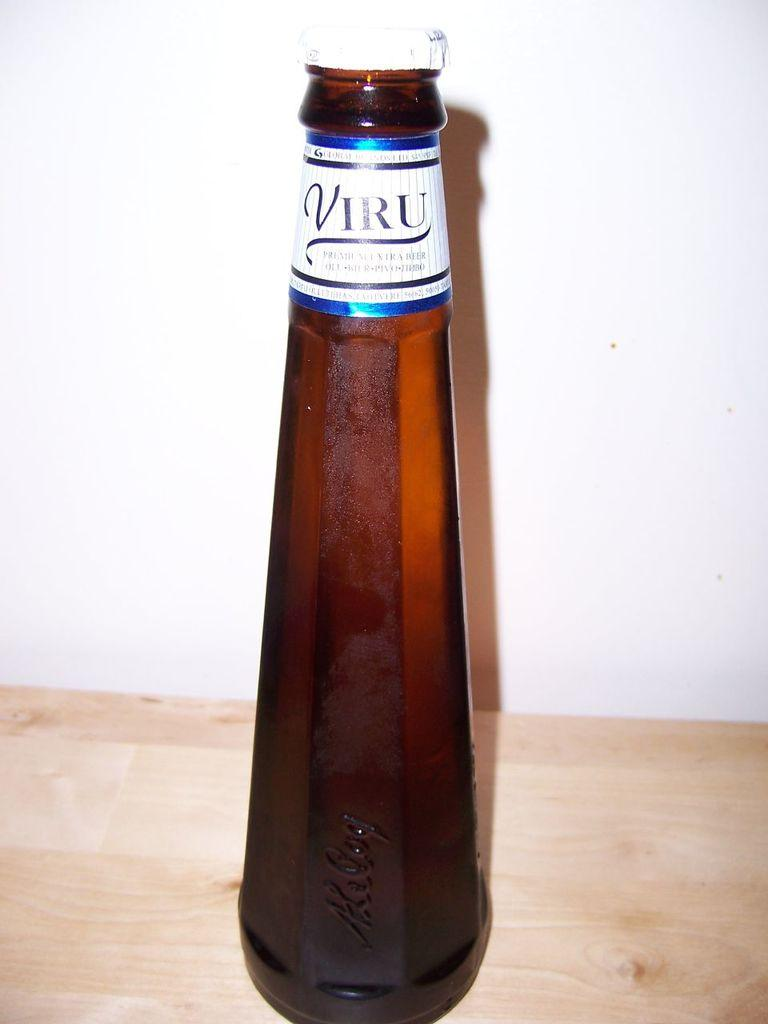<image>
Write a terse but informative summary of the picture. A bottle with Viru written on it sits on a wood shelf. 